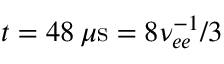<formula> <loc_0><loc_0><loc_500><loc_500>t = 4 8 \, \mu s = 8 \nu _ { e e } ^ { - 1 } / 3</formula> 